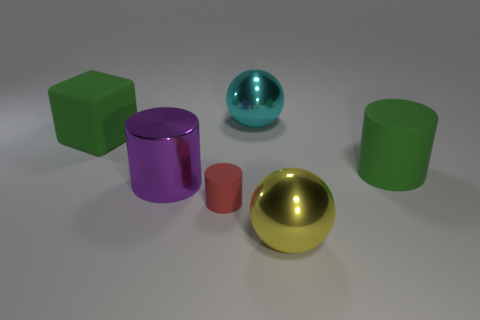Subtract all large purple cylinders. How many cylinders are left? 2 Subtract all blocks. How many objects are left? 5 Subtract all yellow balls. How many balls are left? 1 Add 4 large matte blocks. How many objects exist? 10 Add 2 large cyan shiny things. How many large cyan shiny things are left? 3 Add 5 gray things. How many gray things exist? 5 Subtract 0 yellow cylinders. How many objects are left? 6 Subtract 1 cubes. How many cubes are left? 0 Subtract all purple cylinders. Subtract all cyan cubes. How many cylinders are left? 2 Subtract all yellow objects. Subtract all tiny red cylinders. How many objects are left? 4 